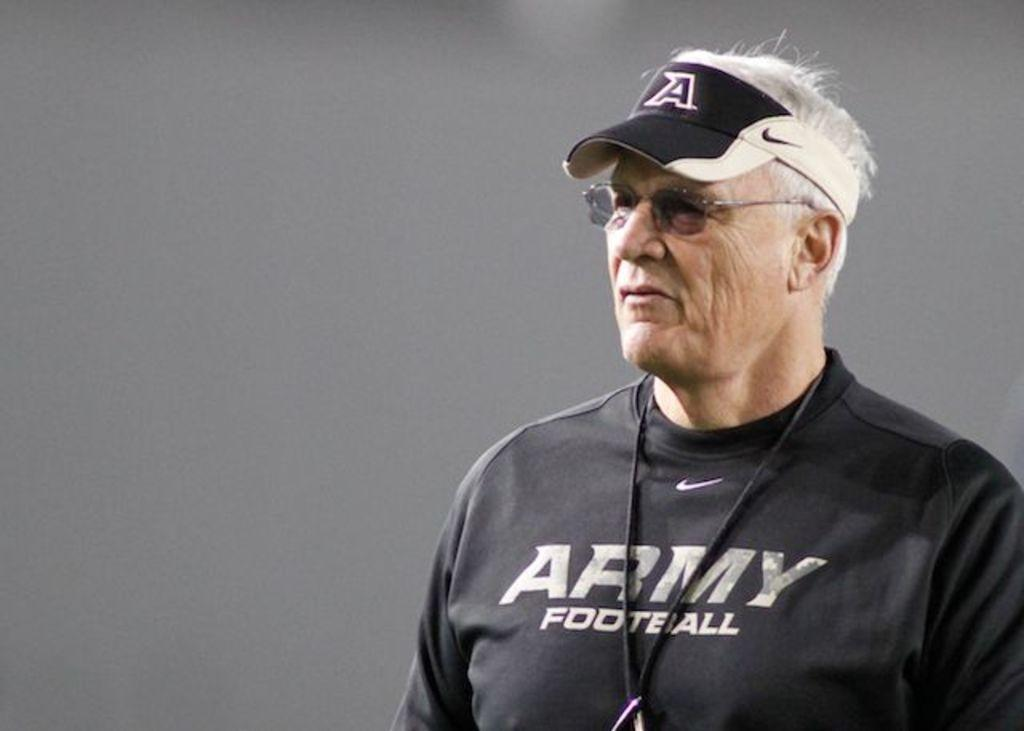<image>
Render a clear and concise summary of the photo. An older man in an Army football shirt. 